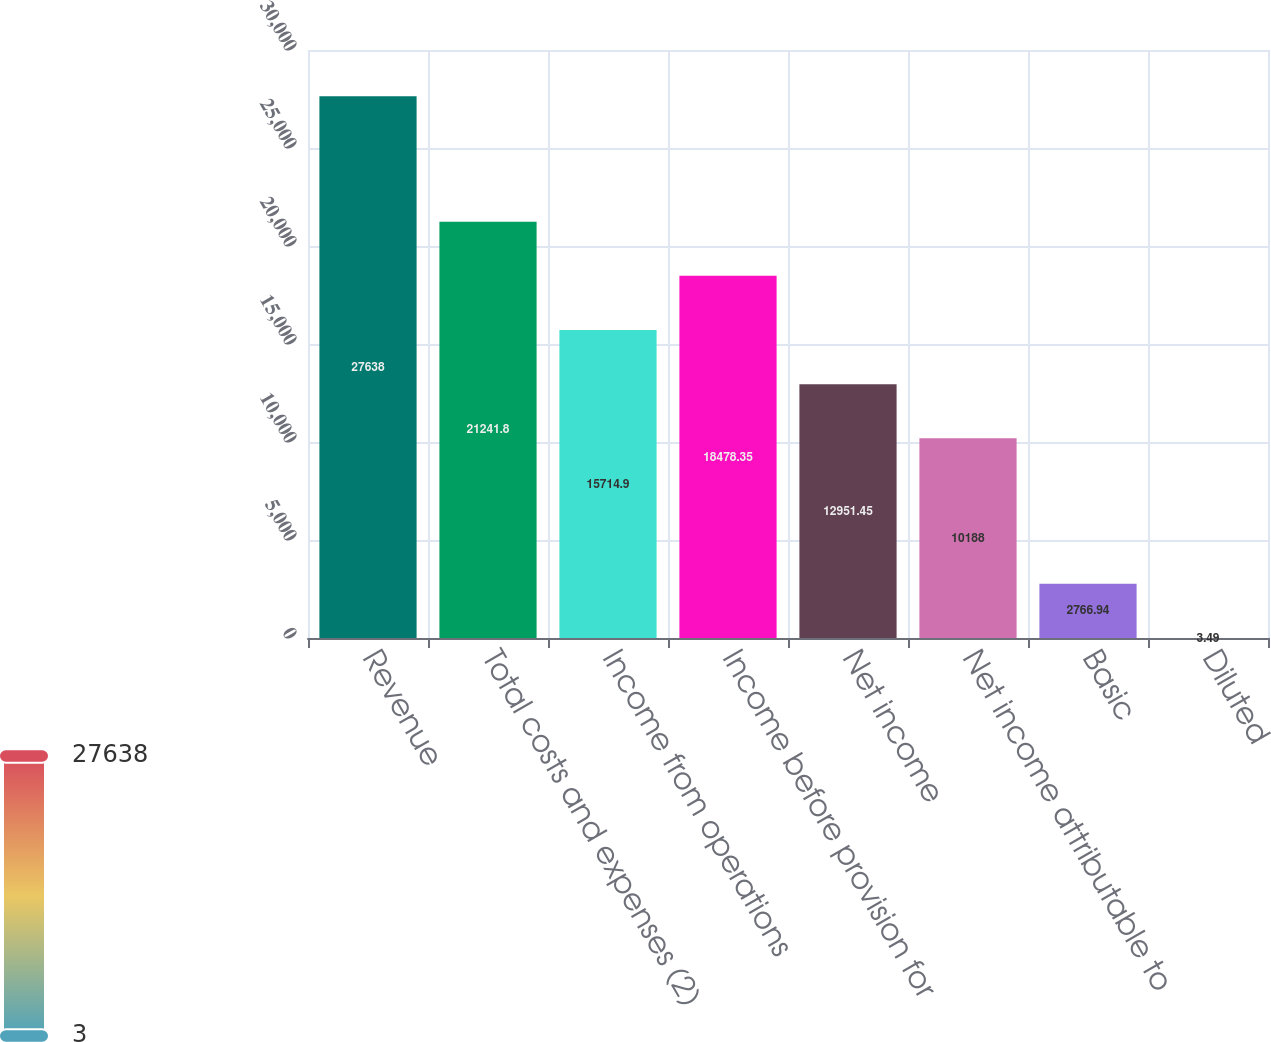Convert chart. <chart><loc_0><loc_0><loc_500><loc_500><bar_chart><fcel>Revenue<fcel>Total costs and expenses (2)<fcel>Income from operations<fcel>Income before provision for<fcel>Net income<fcel>Net income attributable to<fcel>Basic<fcel>Diluted<nl><fcel>27638<fcel>21241.8<fcel>15714.9<fcel>18478.3<fcel>12951.5<fcel>10188<fcel>2766.94<fcel>3.49<nl></chart> 